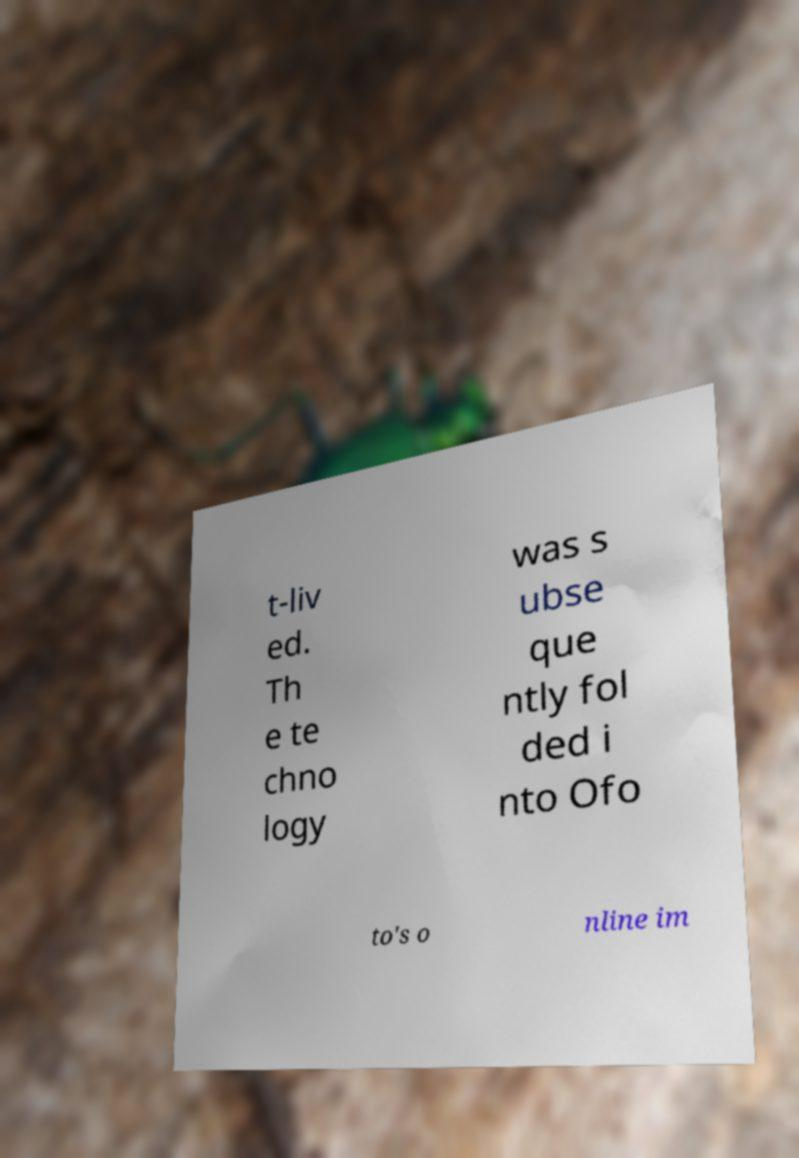For documentation purposes, I need the text within this image transcribed. Could you provide that? t-liv ed. Th e te chno logy was s ubse que ntly fol ded i nto Ofo to's o nline im 